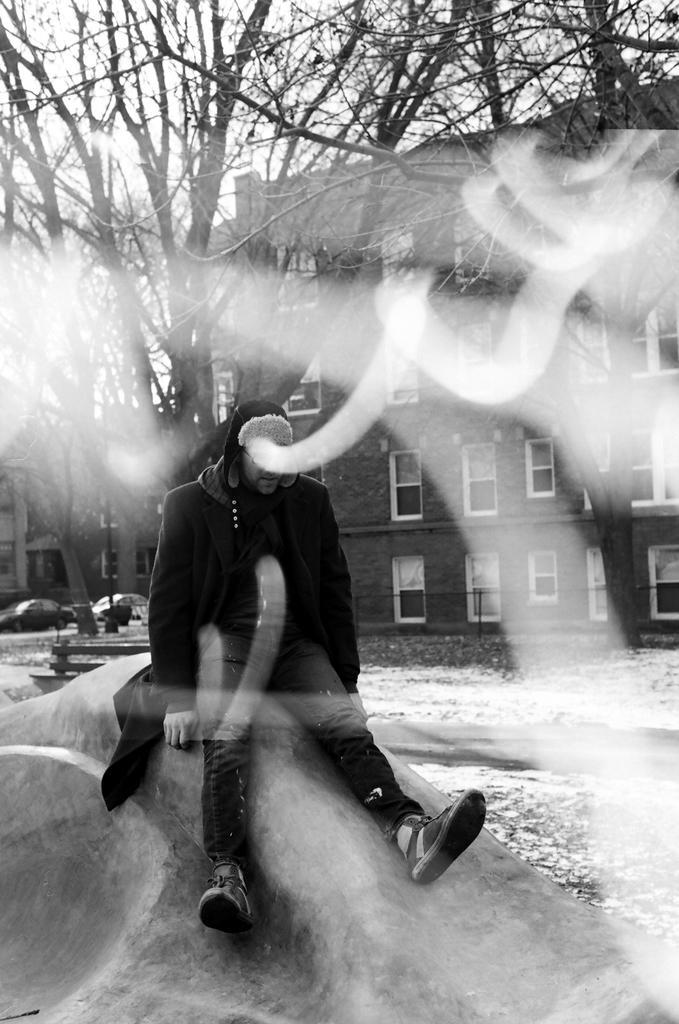Could you give a brief overview of what you see in this image? In this picture I can see a person is sitting. The person is wearing a jacket, pant and shoes. In the background I can see buildings, trees and sky. This picture is black and white in color. On the left side I can see vehicles. 